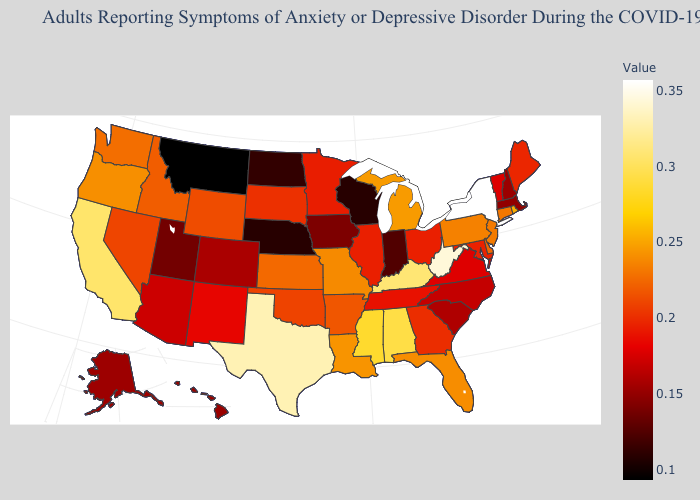Among the states that border Illinois , does Indiana have the lowest value?
Answer briefly. No. Among the states that border Missouri , does Illinois have the highest value?
Write a very short answer. No. 